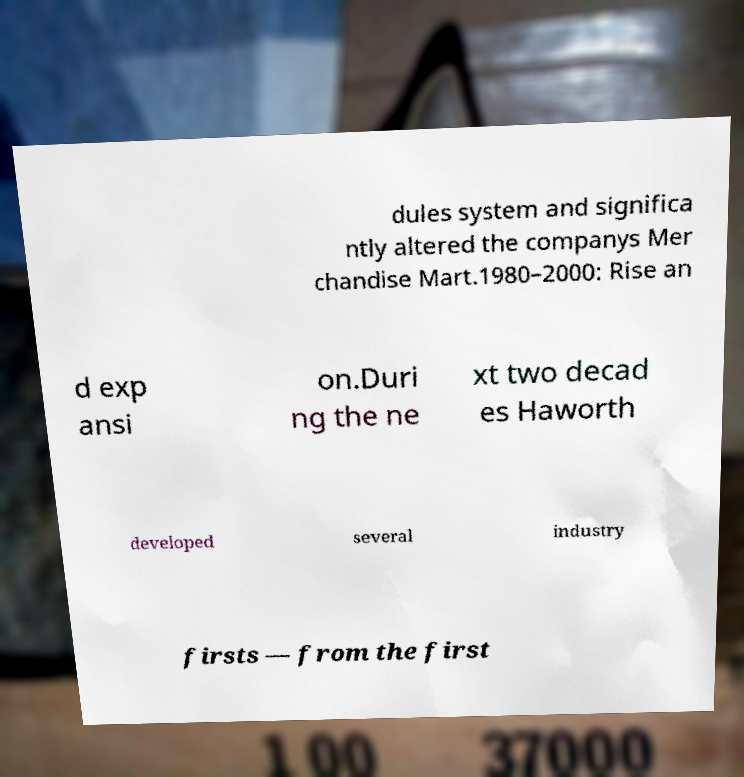For documentation purposes, I need the text within this image transcribed. Could you provide that? dules system and significa ntly altered the companys Mer chandise Mart.1980–2000: Rise an d exp ansi on.Duri ng the ne xt two decad es Haworth developed several industry firsts — from the first 